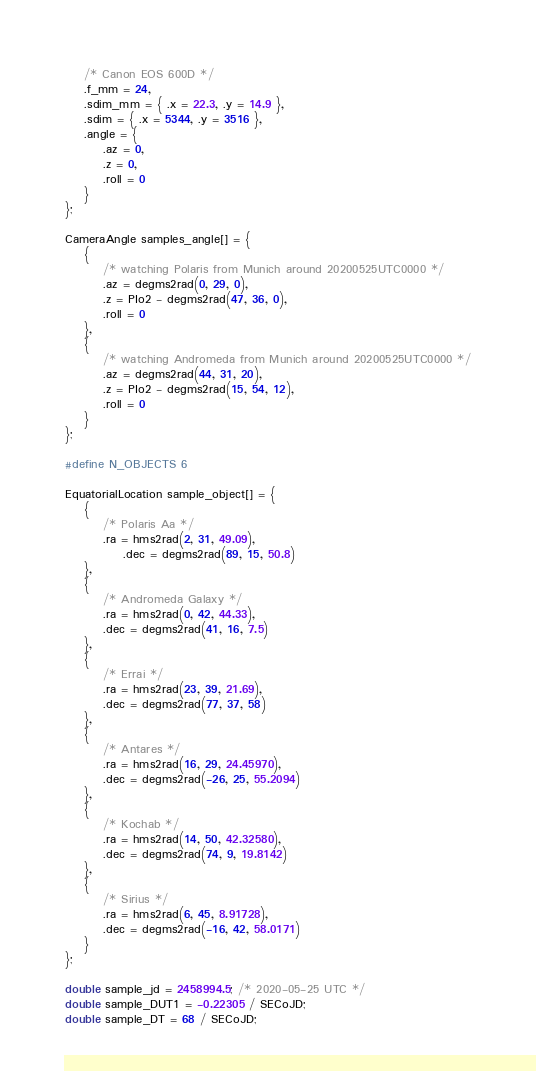Convert code to text. <code><loc_0><loc_0><loc_500><loc_500><_C_>	/* Canon EOS 600D */
	.f_mm = 24,
	.sdim_mm = { .x = 22.3, .y = 14.9 },
	.sdim = { .x = 5344, .y = 3516 },
	.angle = {
		.az = 0,
		.z = 0,
		.roll = 0
	}
};

CameraAngle samples_angle[] = {
	{
		/* watching Polaris from Munich around 20200525UTC0000 */
		.az = degms2rad(0, 29, 0),
		.z = PIo2 - degms2rad(47, 36, 0),
		.roll = 0
	},
	{
		/* watching Andromeda from Munich around 20200525UTC0000 */
		.az = degms2rad(44, 31, 20),
		.z = PIo2 - degms2rad(15, 54, 12),
		.roll = 0
	}
};

#define N_OBJECTS 6

EquatorialLocation sample_object[] = {
	{
		/* Polaris Aa */
		.ra = hms2rad(2, 31, 49.09),
			.dec = degms2rad(89, 15, 50.8)
	},
	{
		/* Andromeda Galaxy */
		.ra = hms2rad(0, 42, 44.33),
		.dec = degms2rad(41, 16, 7.5)
	},
	{
		/* Errai */
		.ra = hms2rad(23, 39, 21.69),
		.dec = degms2rad(77, 37, 58)
	},
	{
		/* Antares */
		.ra = hms2rad(16, 29, 24.45970),
		.dec = degms2rad(-26, 25, 55.2094)
	},
	{
		/* Kochab */
		.ra = hms2rad(14, 50, 42.32580),
		.dec = degms2rad(74, 9, 19.8142)
	},
	{
		/* Sirius */
		.ra = hms2rad(6, 45, 8.91728),
		.dec = degms2rad(-16, 42, 58.0171)
	}
};

double sample_jd = 2458994.5; /* 2020-05-25 UTC */
double sample_DUT1 = -0.22305 / SECoJD;
double sample_DT = 68 / SECoJD;

</code> 